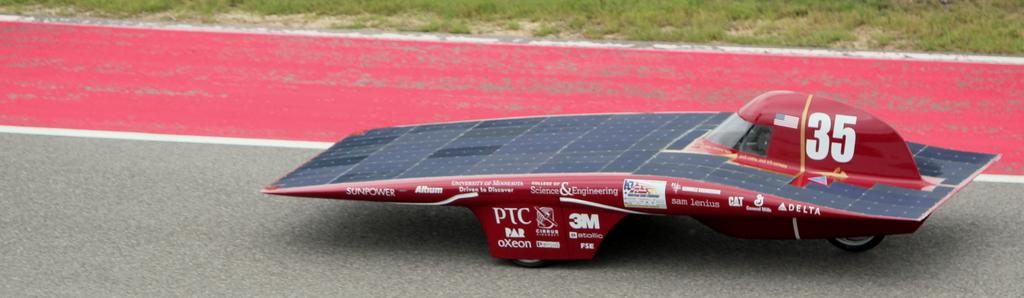What is the main subject in the center of the image? There is a vehicle in the center of the image. What type of natural environment can be seen in the background? There is grass in the background of the image. What type of surface is visible at the bottom of the image? There is a road at the bottom of the image. What type of cream is being used to turn the pages in the image? There is no cream or pages present in the image; it features a vehicle, grass, and a road. 